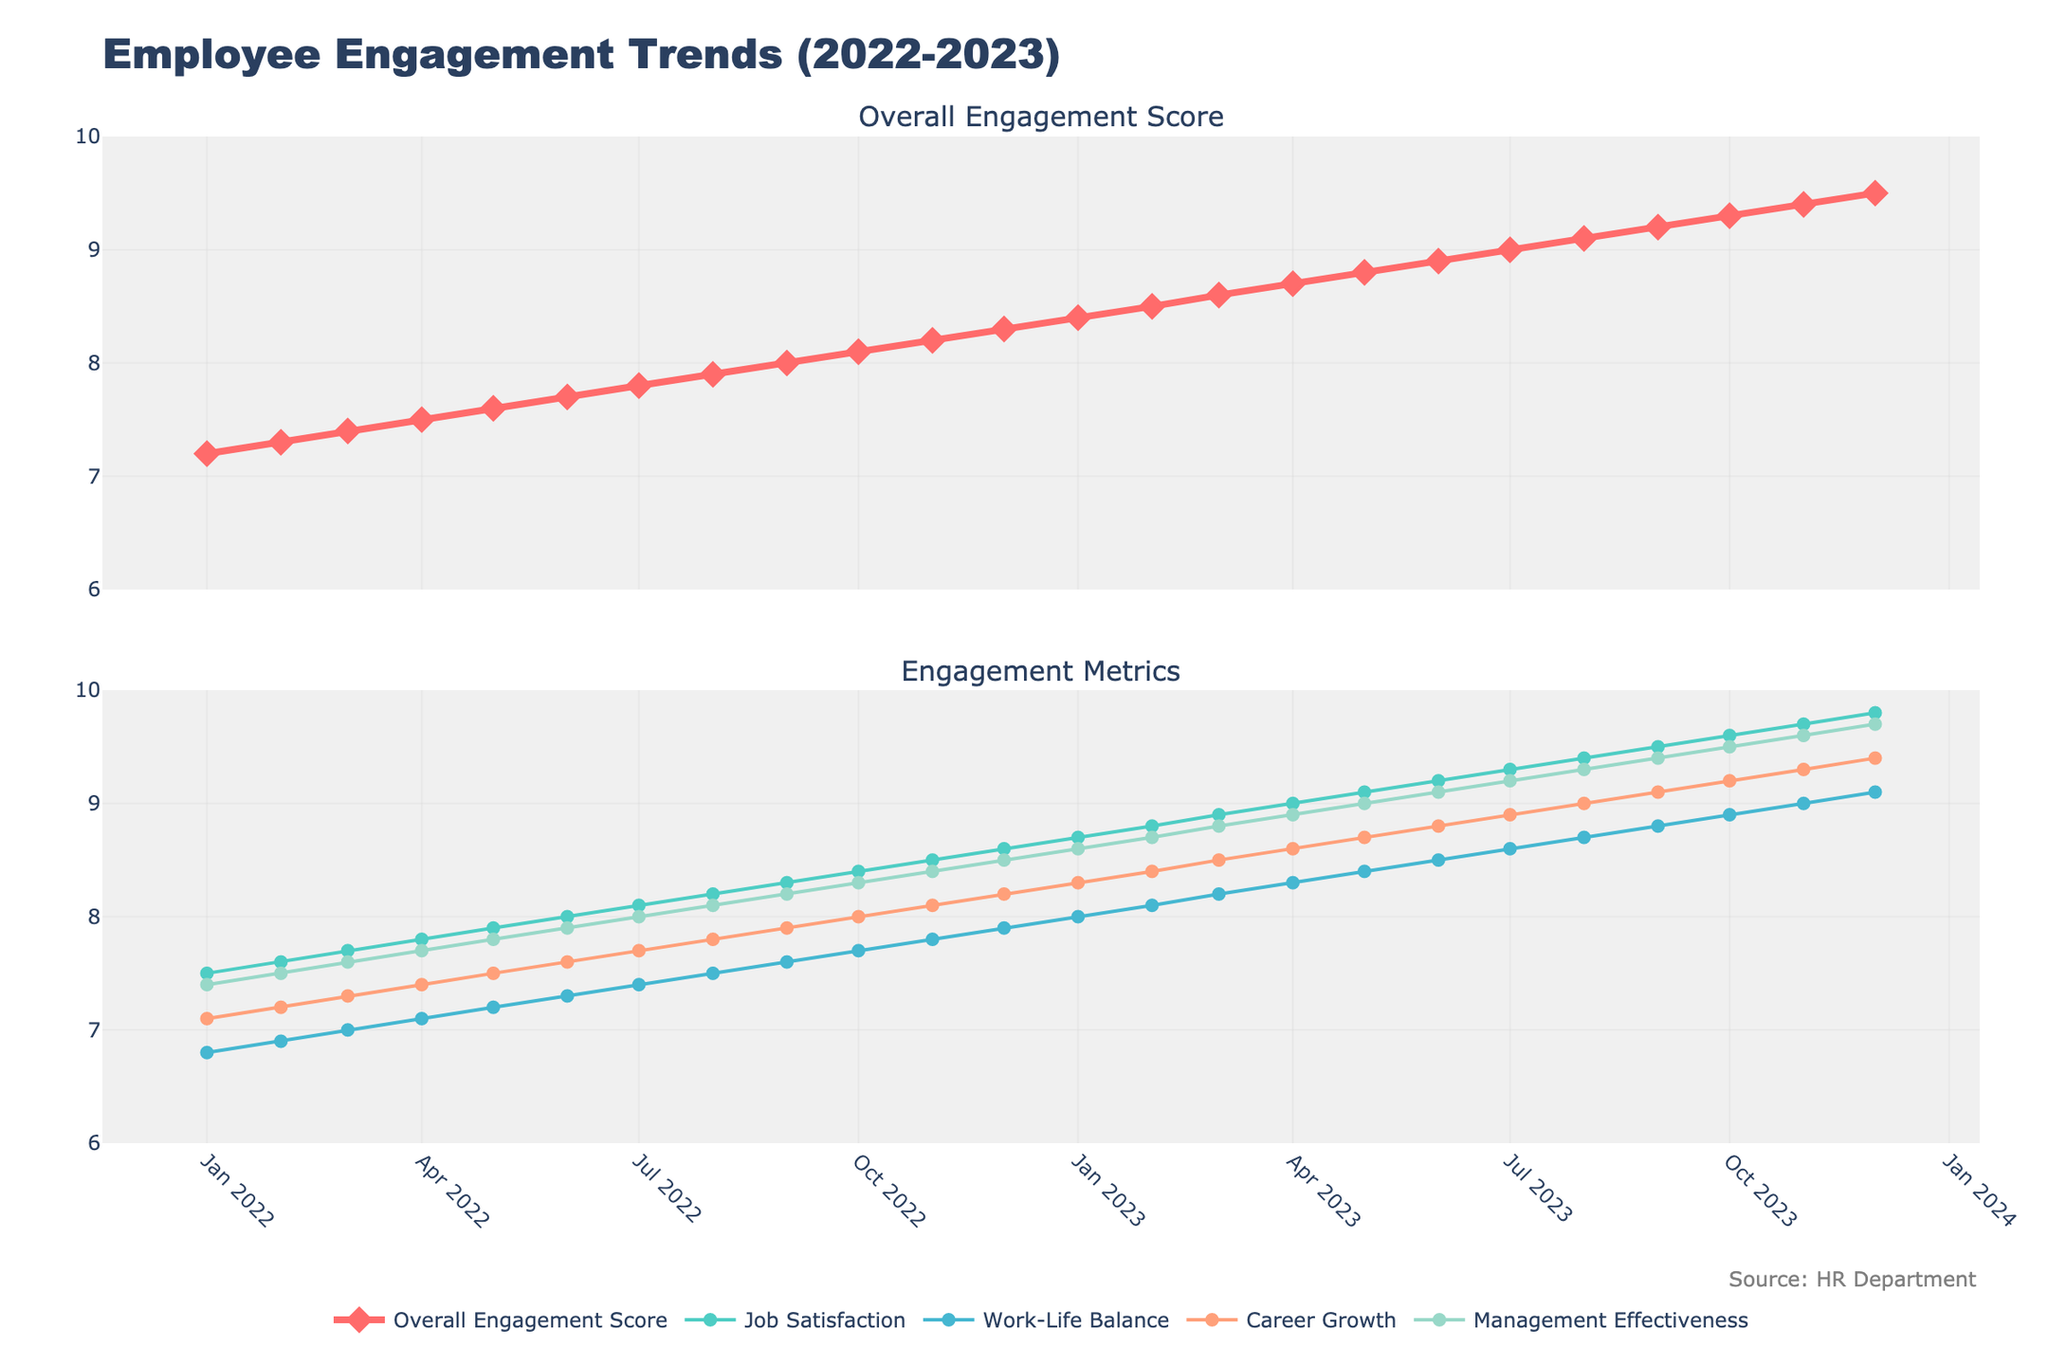What is the overall trend in the Overall Engagement Score from January 2022 to December 2023? The Overall Engagement Score shows a consistent upward trend, starting at 7.2 in January 2022 and reaching 9.5 by December 2023, indicating a steady increase in employee engagement over the two years.
Answer: Upward trend How does Job Satisfaction compare to Work-Life Balance in December 2022? In December 2022, the Job Satisfaction score is 8.6 while the Work-Life Balance score is 7.9. By comparing these two values, we see that Job Satisfaction is higher.
Answer: Job Satisfaction is higher What is the average Overall Engagement Score for the year 2022? To find the average for 2022, sum the Monthly Overall Engagement Scores from January to December 2022 and divide by 12: (7.2+7.3+7.4+7.5+7.6+7.7+7.8+7.9+8.0+8.1+8.2+8.3)/12 = 89.0/12 ≈ 7.42
Answer: 7.42 Which month shows the highest increase in Career Growth score between consecutive months? By comparing the differences month by month, the largest increase in Career Growth score is from December 2022 (8.2) to January 2023 (8.3), but further significant increases are noted in many months without a single "highest."
Answer: Notable increase in several months How does Management Effectiveness in January 2022 compare to December 2023? In January 2022, Management Effectiveness is 7.4, whereas by December 2023, it has increased to 9.7, indicating a substantial improvement.
Answer: Substantial improvement Which metric shows the smallest improvement from January 2022 to December 2023? Work-Life Balance scores increased from 6.8 in January 2022 to 9.1 in December 2023, which is an increase of 2.3, compared to other metrics with larger increases.
Answer: Work-Life Balance Between which two months was the largest drop in Work-Life Balance score observed? By examining the graph, it can be noted that there are no drops in the Work-Life Balance score; it shows a consistent upward trend.
Answer: No drops observed What is the overall pattern observed in Management Effectiveness scores over the two years? Management Effectiveness shows a continuous improvement from 7.4 in January 2022 to 9.7 in December 2023. The trend line is consistently upward demonstrating gradual improvement each month.
Answer: Continuous improvement How does the average Job Satisfaction score for 2023 compare to that for 2022? Average for 2022: (7.5+7.6+7.7+7.8+7.9+8.0+8.1+8.2+8.3+8.4+8.5+8.6)/12 = 93.6/12 ≈ 7.8; Average for 2023: (8.7+8.8+8.9+9.0+9.1+9.2+9.3+9.4+9.5+9.6+9.7+9.8)/12 = 108.0/12 = 9.0; The average Job Satisfaction score for 2023 is higher than for 2022.
Answer: Higher in 2023 